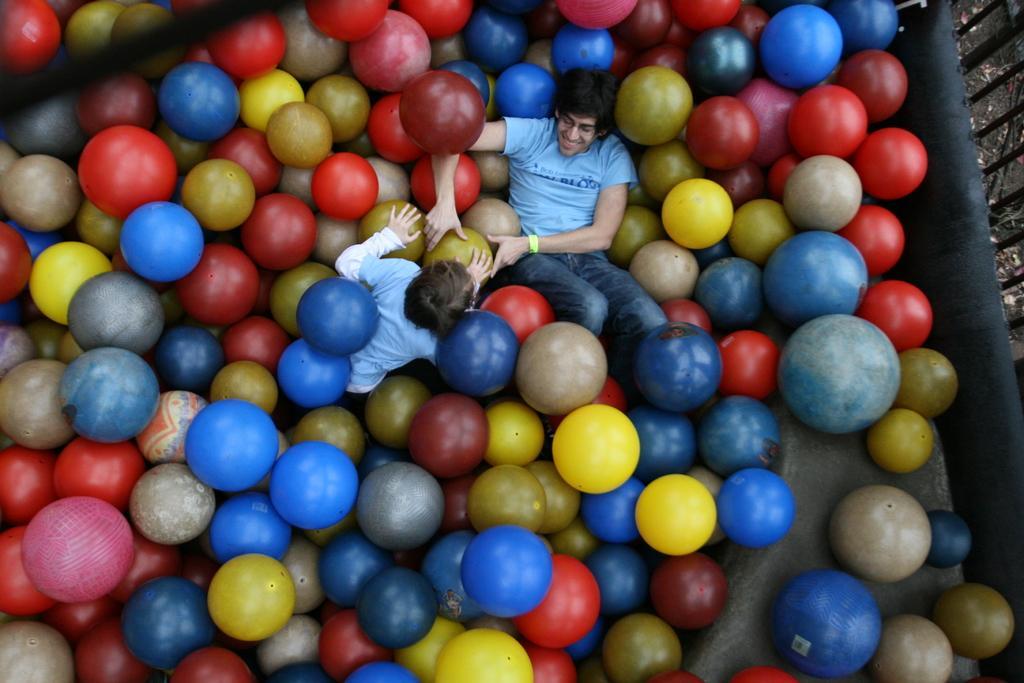Please provide a concise description of this image. There are two people and we can see balls and fence. 